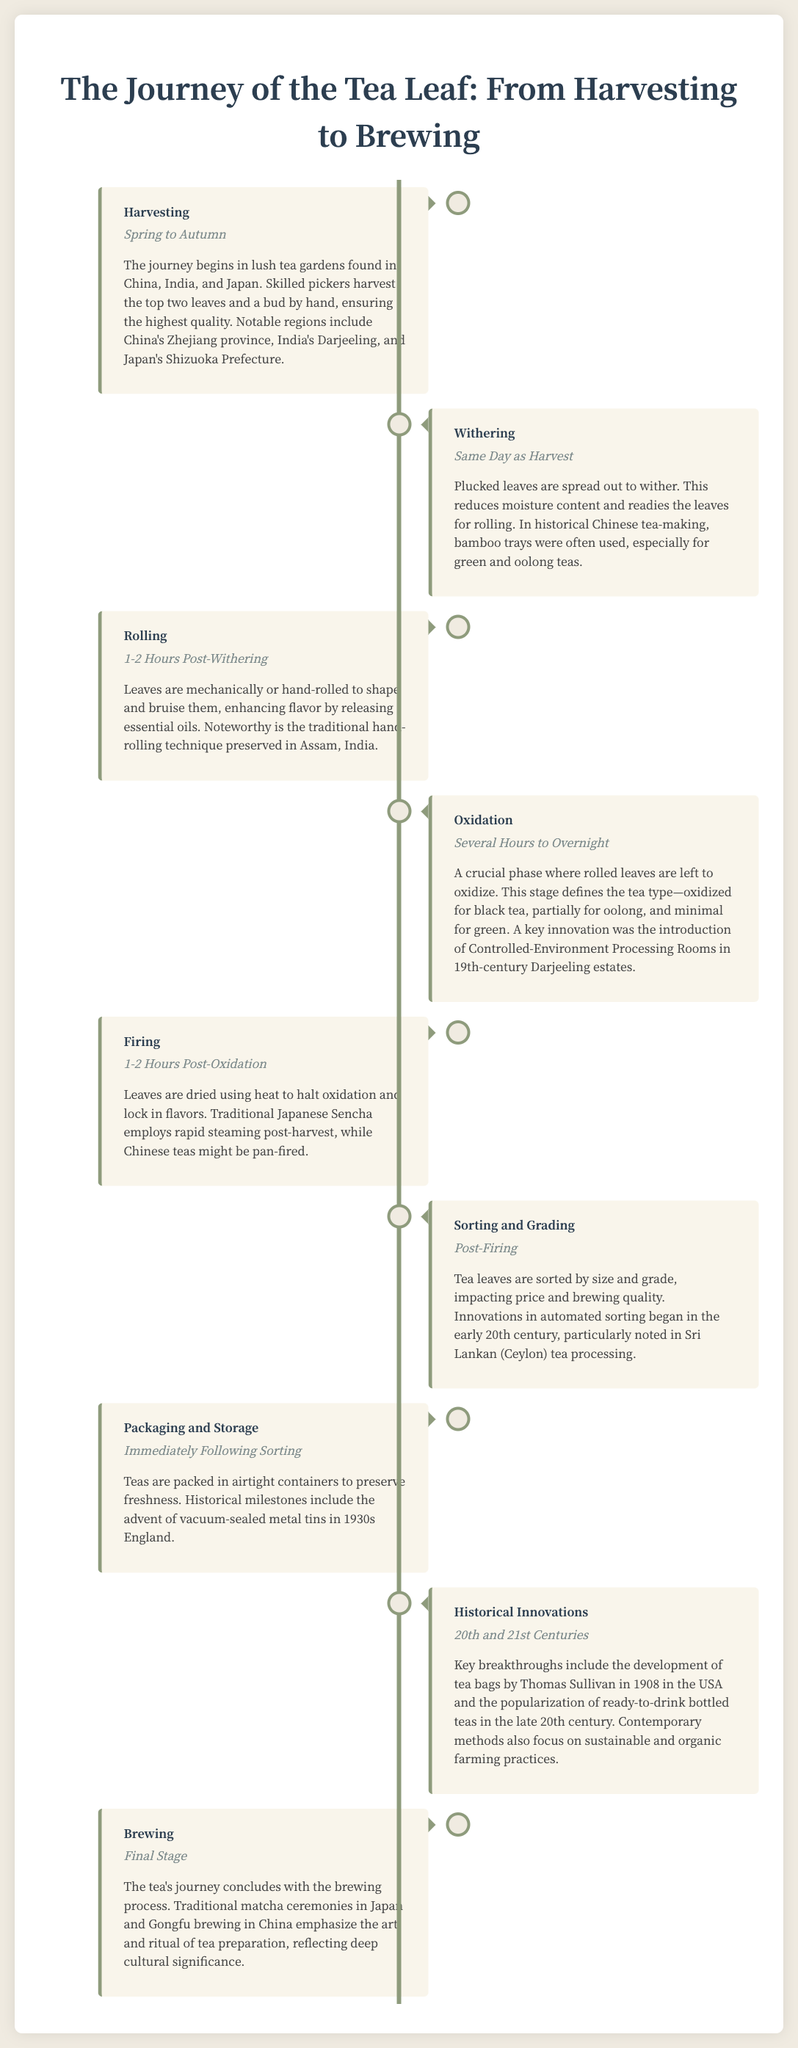What is the first stage in the tea leaf journey? The document lists Harvesting as the first stage in the tea leaf journey.
Answer: Harvesting During which period do the leaves begin withering? The document states the withering process occurs on the same day as harvesting.
Answer: Same Day as Harvest What primary technique is used in the rolling stage? The entry for Rolling mentions that leaves are either mechanically or hand-rolled to shape and bruise them.
Answer: Hand-rolled What defines the type of tea during the oxidation stage? The oxidation phase determines whether the tea is black, oolong, or green based on the level of oxidation.
Answer: Type of tea Which region is notable for its traditional hand-rolling technique? The entry for Rolling highlights Assam, India as a notable region for hand-rolling tea leaves.
Answer: Assam What innovation was introduced in 19th-century Darjeeling estates? The document mentions the introduction of Controlled-Environment Processing Rooms as a key innovation in Darjeeling.
Answer: Controlled-Environment Processing Rooms What historical milestone in tea packaging occurred in the 1930s? The document states the advent of vacuum-sealed metal tins in England as a significant milestone in tea packaging.
Answer: Vacuum-sealed metal tins What cultural significance is emphasized in the brewing stage? The document notes that traditional matcha ceremonies and Gongfu brewing reflect deep cultural significance in tea preparation.
Answer: Cultural significance 